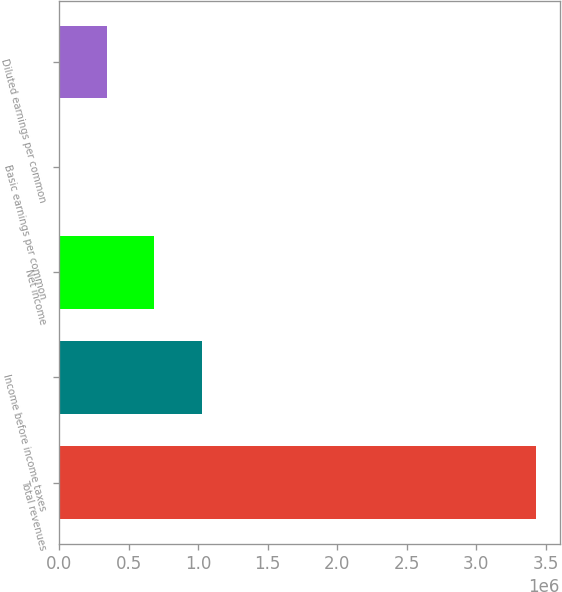<chart> <loc_0><loc_0><loc_500><loc_500><bar_chart><fcel>Total revenues<fcel>Income before income taxes<fcel>Net income<fcel>Basic earnings per common<fcel>Diluted earnings per common<nl><fcel>3.43148e+06<fcel>1.02944e+06<fcel>686296<fcel>0.5<fcel>343148<nl></chart> 